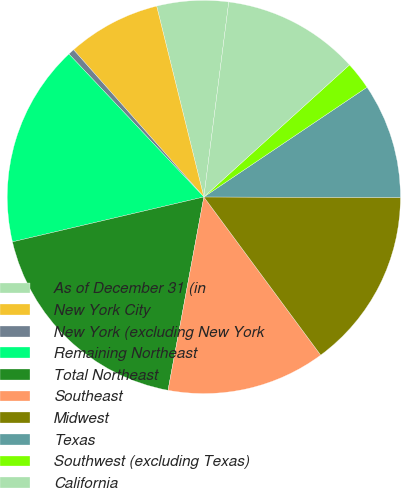<chart> <loc_0><loc_0><loc_500><loc_500><pie_chart><fcel>As of December 31 (in<fcel>New York City<fcel>New York (excluding New York<fcel>Remaining Northeast<fcel>Total Northeast<fcel>Southeast<fcel>Midwest<fcel>Texas<fcel>Southwest (excluding Texas)<fcel>California<nl><fcel>5.88%<fcel>7.67%<fcel>0.51%<fcel>16.62%<fcel>18.41%<fcel>13.04%<fcel>14.83%<fcel>9.46%<fcel>2.3%<fcel>11.25%<nl></chart> 